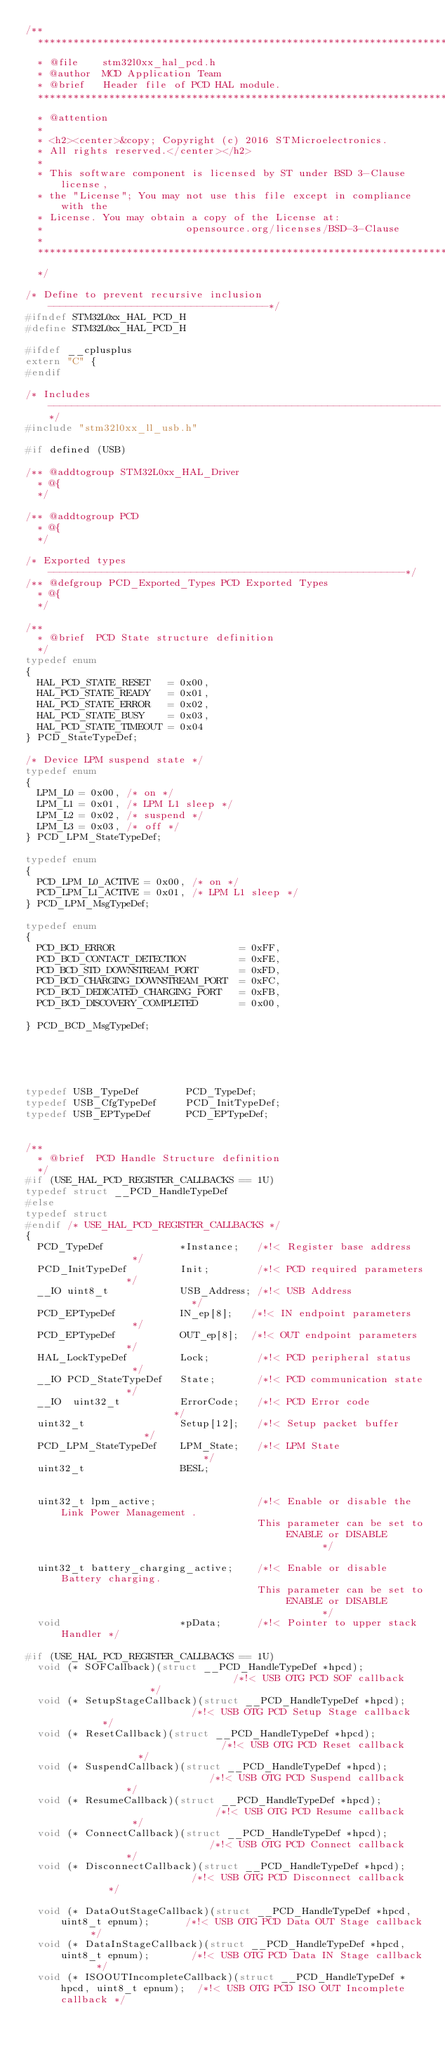Convert code to text. <code><loc_0><loc_0><loc_500><loc_500><_C_>/**
  ******************************************************************************
  * @file    stm32l0xx_hal_pcd.h
  * @author  MCD Application Team
  * @brief   Header file of PCD HAL module.
  ******************************************************************************
  * @attention
  *
  * <h2><center>&copy; Copyright (c) 2016 STMicroelectronics.
  * All rights reserved.</center></h2>
  *
  * This software component is licensed by ST under BSD 3-Clause license,
  * the "License"; You may not use this file except in compliance with the
  * License. You may obtain a copy of the License at:
  *                        opensource.org/licenses/BSD-3-Clause
  *
  ******************************************************************************
  */

/* Define to prevent recursive inclusion -------------------------------------*/
#ifndef STM32L0xx_HAL_PCD_H
#define STM32L0xx_HAL_PCD_H

#ifdef __cplusplus
extern "C" {
#endif

/* Includes ------------------------------------------------------------------*/
#include "stm32l0xx_ll_usb.h"

#if defined (USB)

/** @addtogroup STM32L0xx_HAL_Driver
  * @{
  */

/** @addtogroup PCD
  * @{
  */

/* Exported types ------------------------------------------------------------*/
/** @defgroup PCD_Exported_Types PCD Exported Types
  * @{
  */

/**
  * @brief  PCD State structure definition
  */
typedef enum
{
  HAL_PCD_STATE_RESET   = 0x00,
  HAL_PCD_STATE_READY   = 0x01,
  HAL_PCD_STATE_ERROR   = 0x02,
  HAL_PCD_STATE_BUSY    = 0x03,
  HAL_PCD_STATE_TIMEOUT = 0x04
} PCD_StateTypeDef;

/* Device LPM suspend state */
typedef enum
{
  LPM_L0 = 0x00, /* on */
  LPM_L1 = 0x01, /* LPM L1 sleep */
  LPM_L2 = 0x02, /* suspend */
  LPM_L3 = 0x03, /* off */
} PCD_LPM_StateTypeDef;

typedef enum
{
  PCD_LPM_L0_ACTIVE = 0x00, /* on */
  PCD_LPM_L1_ACTIVE = 0x01, /* LPM L1 sleep */
} PCD_LPM_MsgTypeDef;

typedef enum
{
  PCD_BCD_ERROR                     = 0xFF,
  PCD_BCD_CONTACT_DETECTION         = 0xFE,
  PCD_BCD_STD_DOWNSTREAM_PORT       = 0xFD,
  PCD_BCD_CHARGING_DOWNSTREAM_PORT  = 0xFC,
  PCD_BCD_DEDICATED_CHARGING_PORT   = 0xFB,
  PCD_BCD_DISCOVERY_COMPLETED       = 0x00,

} PCD_BCD_MsgTypeDef;





typedef USB_TypeDef        PCD_TypeDef;
typedef USB_CfgTypeDef     PCD_InitTypeDef;
typedef USB_EPTypeDef      PCD_EPTypeDef;


/**
  * @brief  PCD Handle Structure definition
  */
#if (USE_HAL_PCD_REGISTER_CALLBACKS == 1U)
typedef struct __PCD_HandleTypeDef
#else
typedef struct
#endif /* USE_HAL_PCD_REGISTER_CALLBACKS */
{
  PCD_TypeDef             *Instance;   /*!< Register base address             */
  PCD_InitTypeDef         Init;        /*!< PCD required parameters           */
  __IO uint8_t            USB_Address; /*!< USB Address                       */
  PCD_EPTypeDef           IN_ep[8];   /*!< IN endpoint parameters             */
  PCD_EPTypeDef           OUT_ep[8];  /*!< OUT endpoint parameters            */
  HAL_LockTypeDef         Lock;        /*!< PCD peripheral status             */
  __IO PCD_StateTypeDef   State;       /*!< PCD communication state           */
  __IO  uint32_t          ErrorCode;   /*!< PCD Error code                    */
  uint32_t                Setup[12];   /*!< Setup packet buffer               */
  PCD_LPM_StateTypeDef    LPM_State;   /*!< LPM State                         */
  uint32_t                BESL;


  uint32_t lpm_active;                 /*!< Enable or disable the Link Power Management .
                                       This parameter can be set to ENABLE or DISABLE        */

  uint32_t battery_charging_active;    /*!< Enable or disable Battery charging.
                                       This parameter can be set to ENABLE or DISABLE        */
  void                    *pData;      /*!< Pointer to upper stack Handler */

#if (USE_HAL_PCD_REGISTER_CALLBACKS == 1U)
  void (* SOFCallback)(struct __PCD_HandleTypeDef *hpcd);                              /*!< USB OTG PCD SOF callback                */
  void (* SetupStageCallback)(struct __PCD_HandleTypeDef *hpcd);                       /*!< USB OTG PCD Setup Stage callback        */
  void (* ResetCallback)(struct __PCD_HandleTypeDef *hpcd);                            /*!< USB OTG PCD Reset callback              */
  void (* SuspendCallback)(struct __PCD_HandleTypeDef *hpcd);                          /*!< USB OTG PCD Suspend callback            */
  void (* ResumeCallback)(struct __PCD_HandleTypeDef *hpcd);                           /*!< USB OTG PCD Resume callback             */
  void (* ConnectCallback)(struct __PCD_HandleTypeDef *hpcd);                          /*!< USB OTG PCD Connect callback            */
  void (* DisconnectCallback)(struct __PCD_HandleTypeDef *hpcd);                       /*!< USB OTG PCD Disconnect callback         */

  void (* DataOutStageCallback)(struct __PCD_HandleTypeDef *hpcd, uint8_t epnum);      /*!< USB OTG PCD Data OUT Stage callback     */
  void (* DataInStageCallback)(struct __PCD_HandleTypeDef *hpcd, uint8_t epnum);       /*!< USB OTG PCD Data IN Stage callback      */
  void (* ISOOUTIncompleteCallback)(struct __PCD_HandleTypeDef *hpcd, uint8_t epnum);  /*!< USB OTG PCD ISO OUT Incomplete callback */</code> 